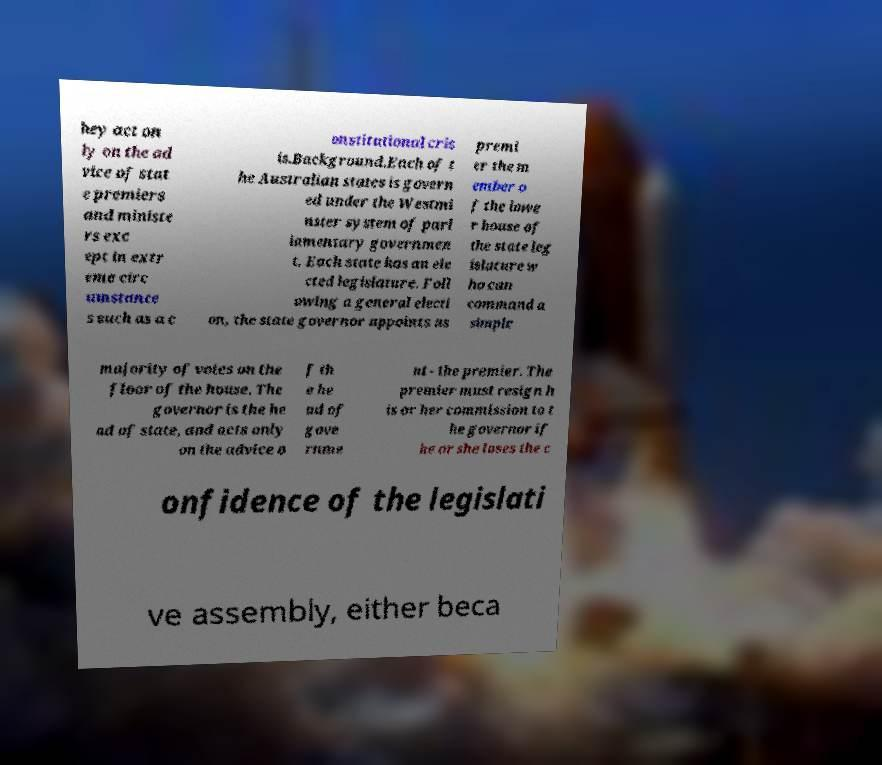Can you accurately transcribe the text from the provided image for me? hey act on ly on the ad vice of stat e premiers and ministe rs exc ept in extr eme circ umstance s such as a c onstitutional cris is.Background.Each of t he Australian states is govern ed under the Westmi nster system of parl iamentary governmen t. Each state has an ele cted legislature. Foll owing a general electi on, the state governor appoints as premi er the m ember o f the lowe r house of the state leg islature w ho can command a simple majority of votes on the floor of the house. The governor is the he ad of state, and acts only on the advice o f th e he ad of gove rnme nt - the premier. The premier must resign h is or her commission to t he governor if he or she loses the c onfidence of the legislati ve assembly, either beca 